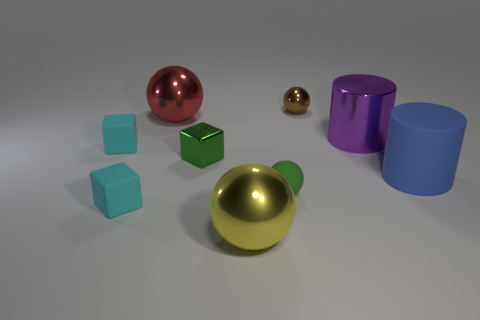Add 1 large brown blocks. How many objects exist? 10 Subtract all blocks. How many objects are left? 6 Add 7 big yellow spheres. How many big yellow spheres are left? 8 Add 1 matte things. How many matte things exist? 5 Subtract 0 red cubes. How many objects are left? 9 Subtract all brown cubes. Subtract all rubber cylinders. How many objects are left? 8 